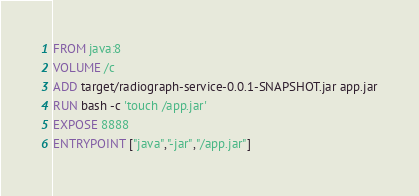Convert code to text. <code><loc_0><loc_0><loc_500><loc_500><_Dockerfile_>FROM java:8
VOLUME /c
ADD target/radiograph-service-0.0.1-SNAPSHOT.jar app.jar
RUN bash -c 'touch /app.jar'
EXPOSE 8888
ENTRYPOINT ["java","-jar","/app.jar"]</code> 